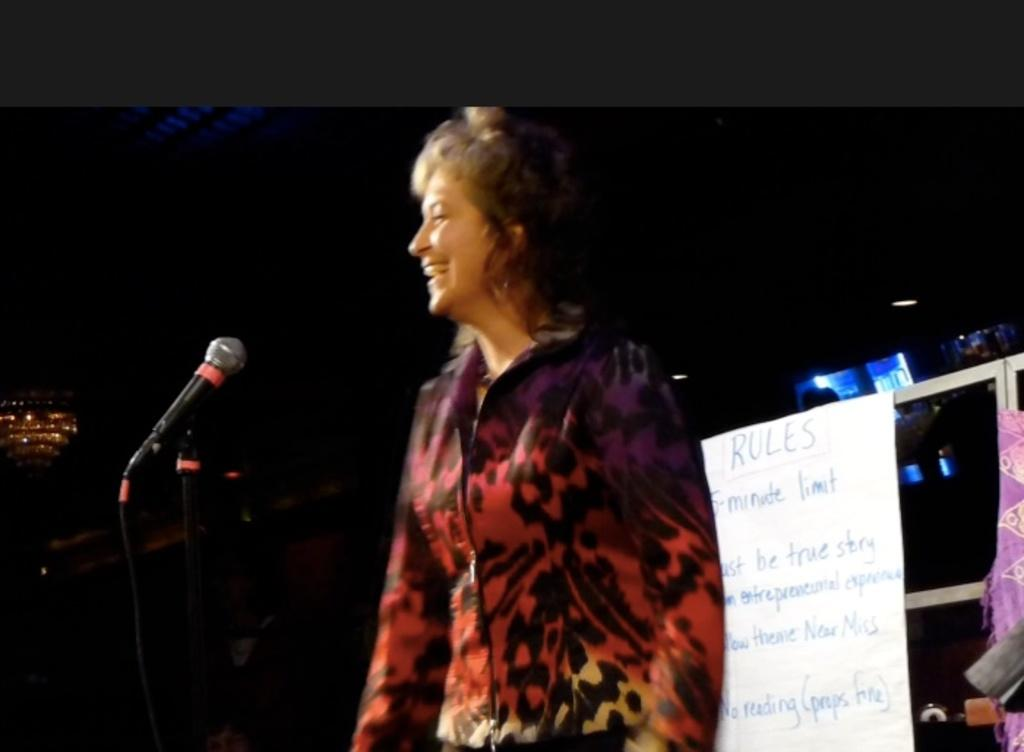What is the main subject of the image? There is a person standing in the image. What object is the person holding? A microphone is visible in the image. What can be seen in the background of the image? There is paper and lights in the background of the image. What shape does the person's sneeze take in the image? There is no sneeze present in the image, so it is not possible to determine its shape. 